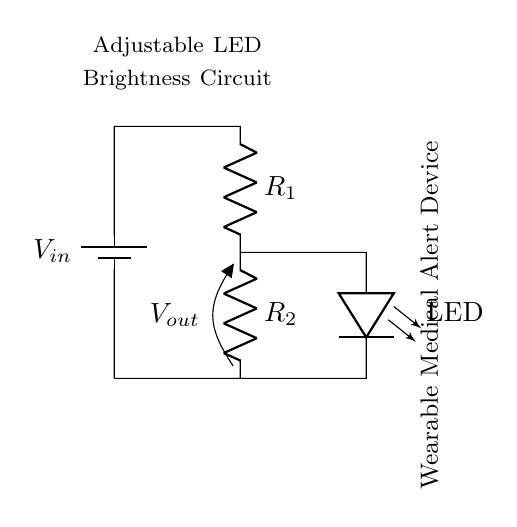What is the input voltage in this circuit? The input voltage is labeled as V_in in the circuit diagram, indicating the voltage source connected to the circuit.
Answer: V_in What is the output voltage across R2? The output voltage is indicated as V_out in the circuit, which is the voltage drop across resistor R2.
Answer: V_out How many resistors are in this circuit? There are two resistors (R1 and R2) in the voltage divider circuit, which are used to control the brightness of the LED.
Answer: 2 What is the primary purpose of the resistors in this circuit? The resistors R1 and R2 in the voltage divider are used to divide the input voltage, which adjusts the current going to the LED for controlling its brightness.
Answer: Adjust LED brightness What is the function of the LED in this circuit? The LED in the circuit serves as an indicator light, showing the operational status of the wearable medical alert device by varying its brightness.
Answer: Indicator light If R1 is twice the resistance of R2, what happens to the output voltage? When R1 is twice R2, the voltage division ratio changes, resulting in V_out being a fraction of V_in based on the resistor values, specifically one-third of V_in.
Answer: One-third of V_in What happens if R2 is removed from the circuit? If R2 is removed, the circuit would be incomplete, causing the LED to receive maximum voltage, potentially damaging it due to excessive current.
Answer: Circuit incomplete 